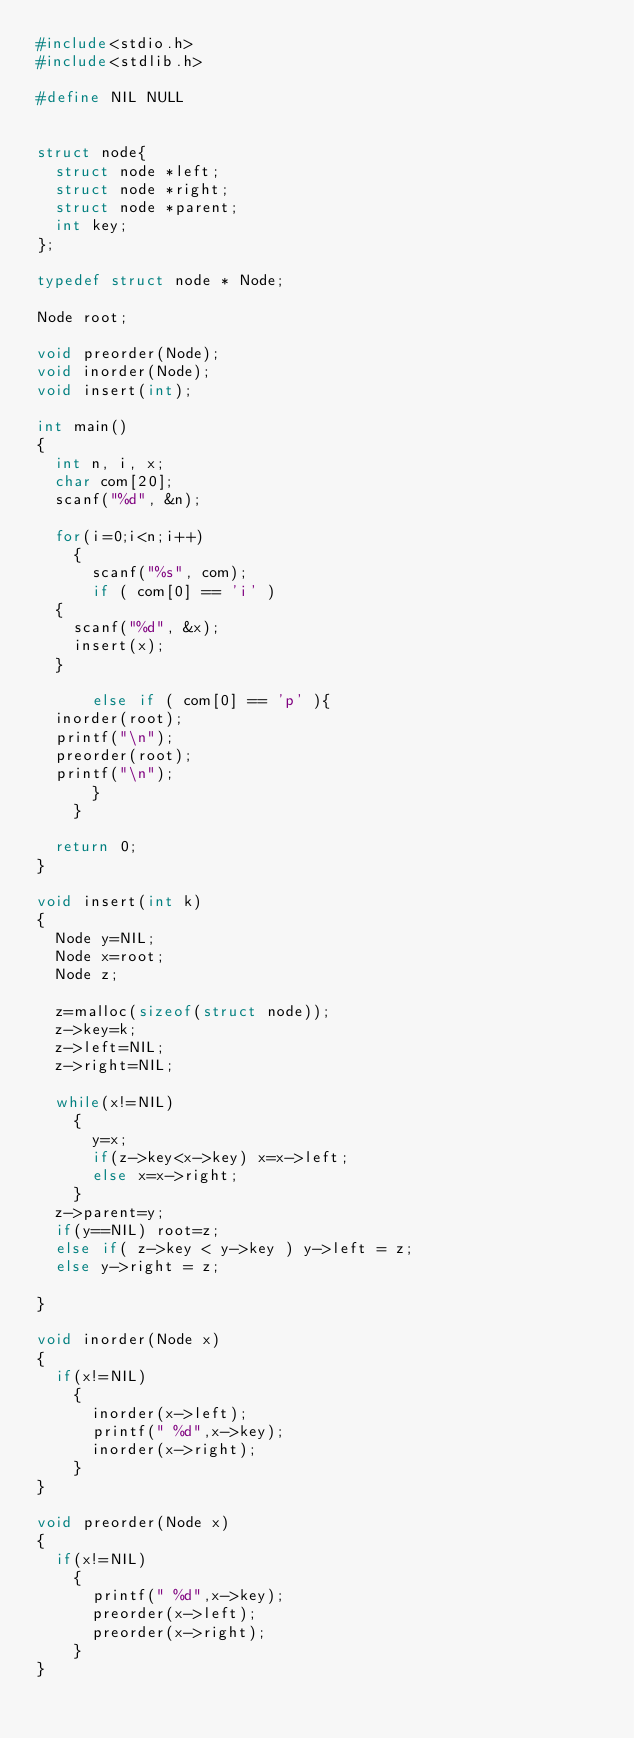<code> <loc_0><loc_0><loc_500><loc_500><_C_>#include<stdio.h>
#include<stdlib.h>

#define NIL NULL


struct node{
  struct node *left;
  struct node *right;
  struct node *parent;
  int key;
};

typedef struct node * Node;

Node root;

void preorder(Node);
void inorder(Node);
void insert(int);

int main()
{
  int n, i, x;
  char com[20];
  scanf("%d", &n);
  
  for(i=0;i<n;i++)
    {
      scanf("%s", com);
      if ( com[0] == 'i' )
	{
	  scanf("%d", &x);
	  insert(x);
	}
      
      else if ( com[0] == 'p' ){
	inorder(root);
	printf("\n");
	preorder(root);
	printf("\n");
      }
    }

  return 0;
}

void insert(int k)
{
  Node y=NIL;
  Node x=root;
  Node z;

  z=malloc(sizeof(struct node));
  z->key=k;
  z->left=NIL;
  z->right=NIL;
  
  while(x!=NIL)
    {
      y=x;
      if(z->key<x->key) x=x->left;
      else x=x->right;
    }
  z->parent=y;
  if(y==NIL) root=z;
  else if( z->key < y->key ) y->left = z;
  else y->right = z;

}

void inorder(Node x)
{
  if(x!=NIL)
    {
      inorder(x->left);
      printf(" %d",x->key);
      inorder(x->right);
    }
}

void preorder(Node x)
{
  if(x!=NIL)
    {
      printf(" %d",x->key);
      preorder(x->left);
      preorder(x->right);
    }
}</code> 